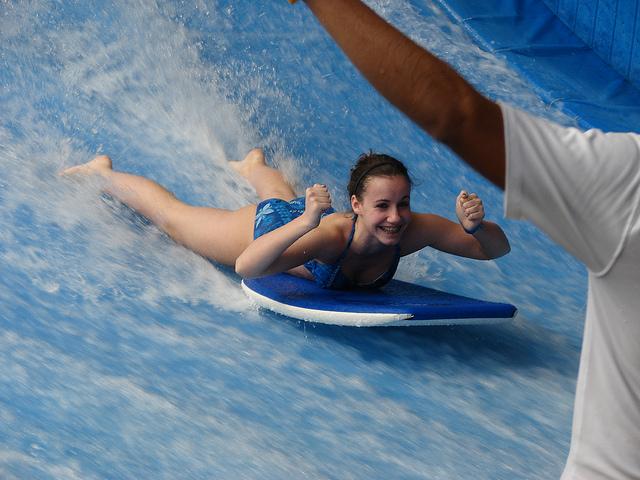What is the girl riding on?
Short answer required. Boogie board. What color is her bathing suit?
Give a very brief answer. Blue. How many people are in the photo?
Give a very brief answer. 2. 